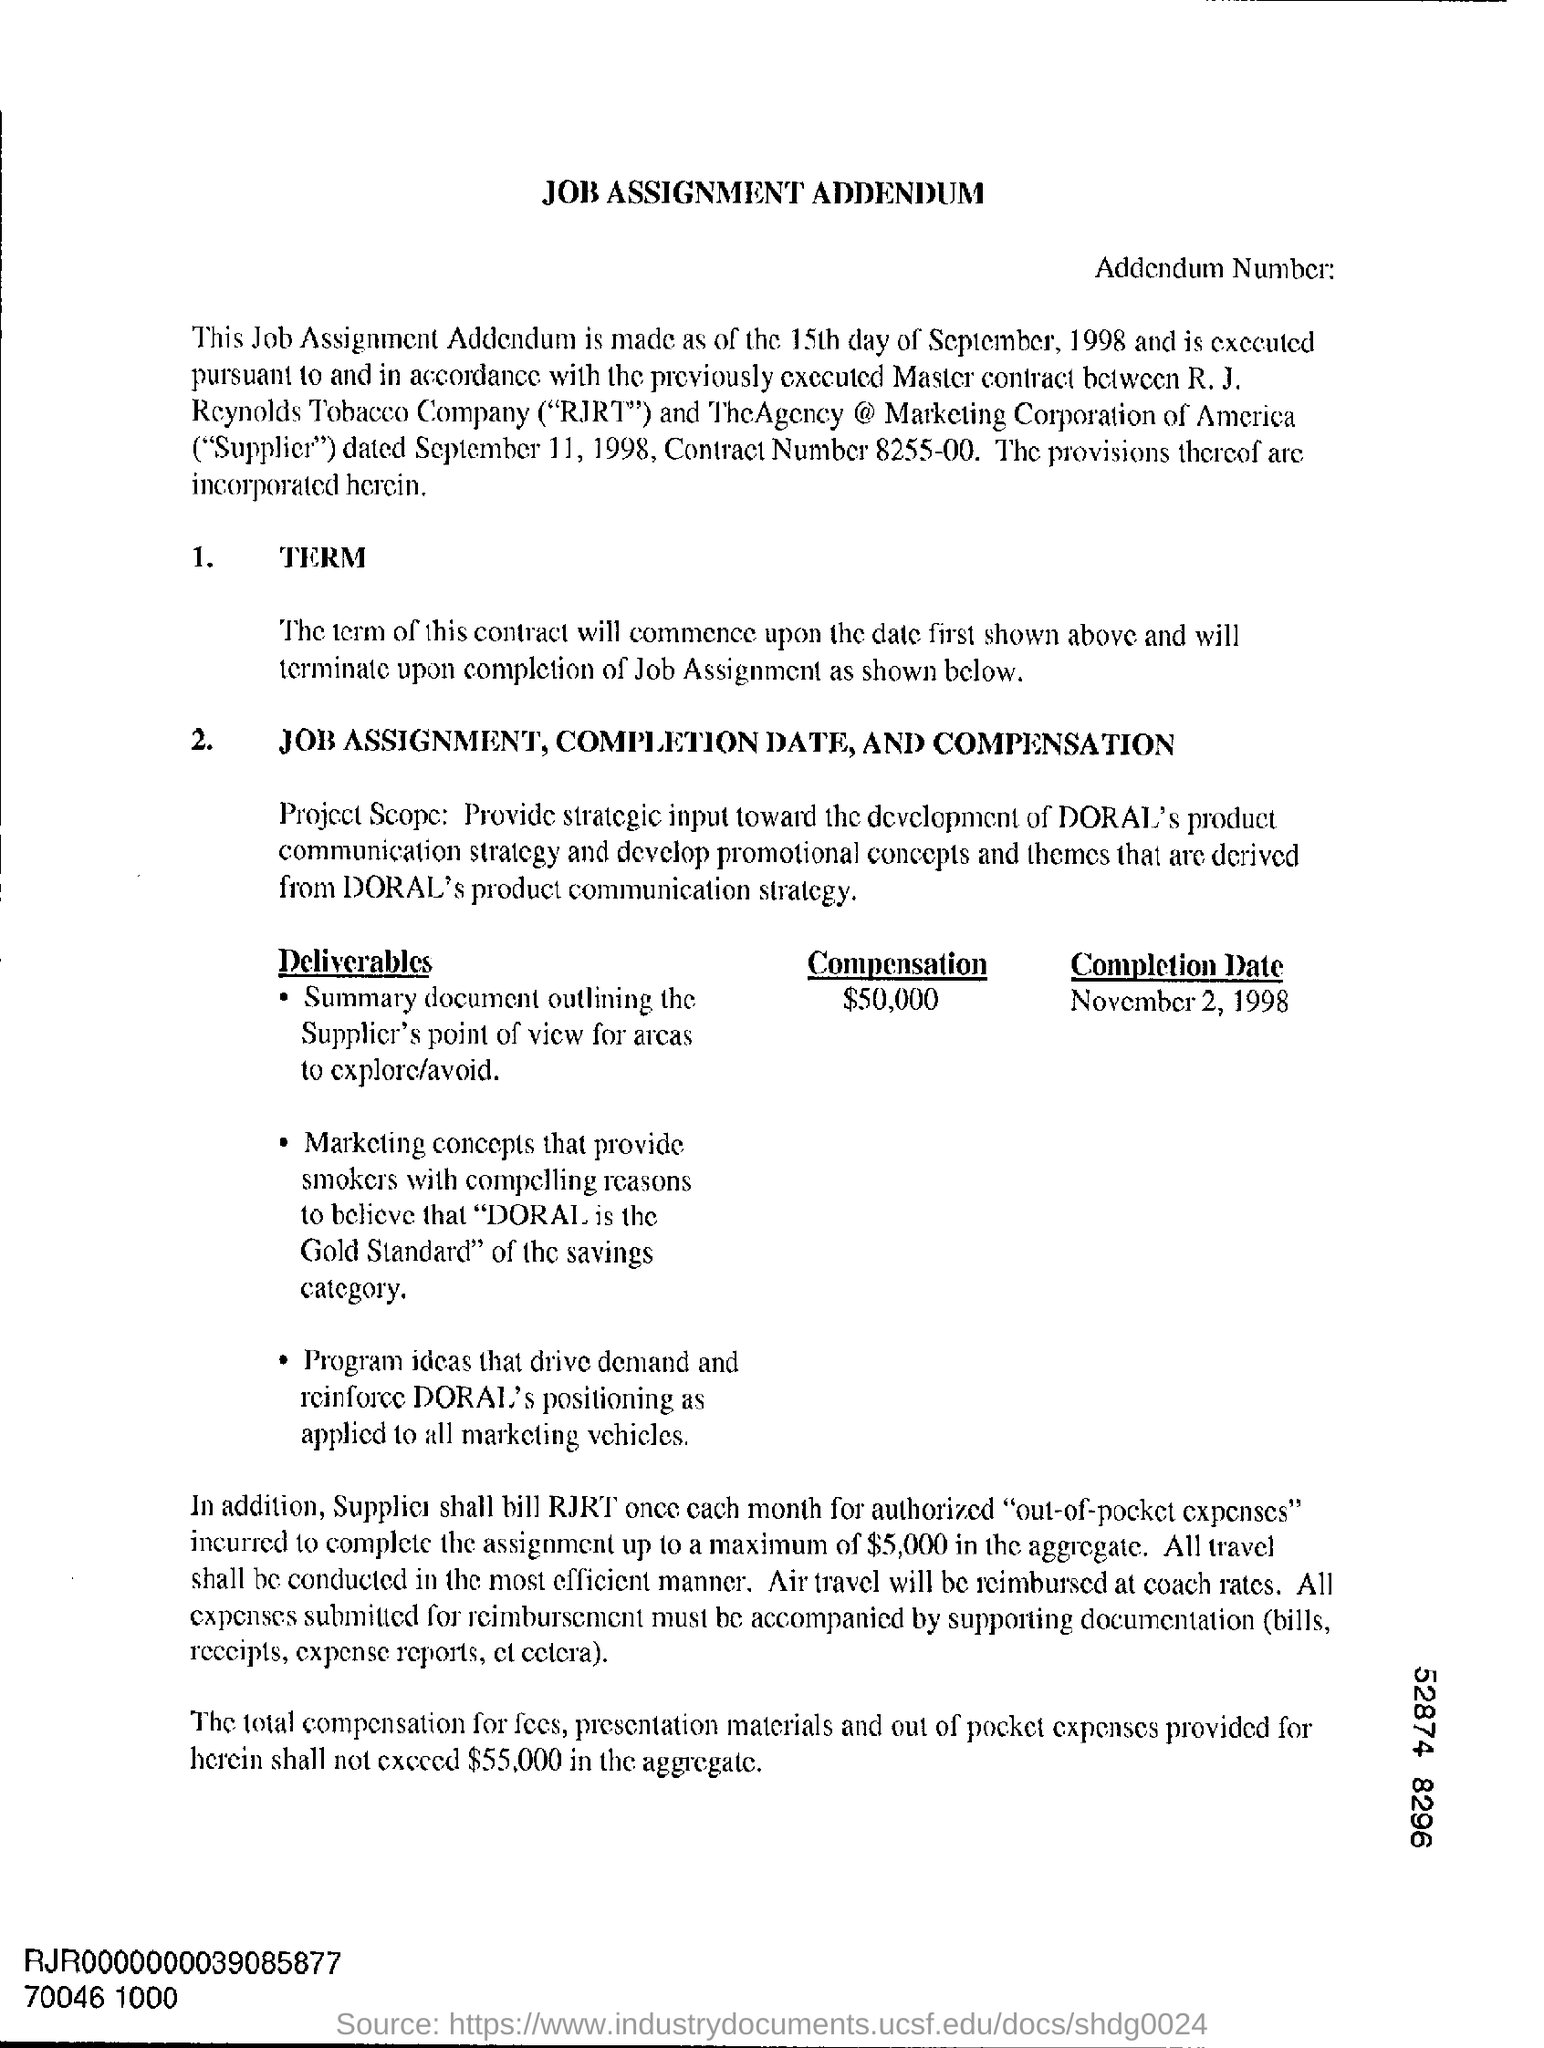What is the heading of the document?
Give a very brief answer. JOB ASSIGNMENT ADDENDUM. What is the Completion Date?
Offer a very short reply. NOVEMBER 2, 1998. When was this addendum made?
Your answer should be very brief. 15th day of September, 1998. 